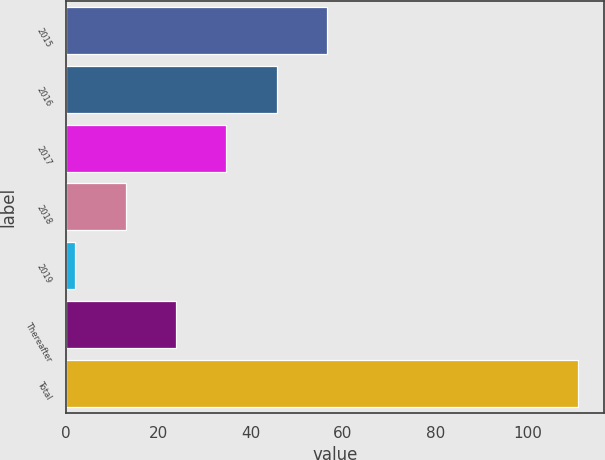<chart> <loc_0><loc_0><loc_500><loc_500><bar_chart><fcel>2015<fcel>2016<fcel>2017<fcel>2018<fcel>2019<fcel>Thereafter<fcel>Total<nl><fcel>56.5<fcel>45.6<fcel>34.7<fcel>12.9<fcel>2<fcel>23.8<fcel>111<nl></chart> 